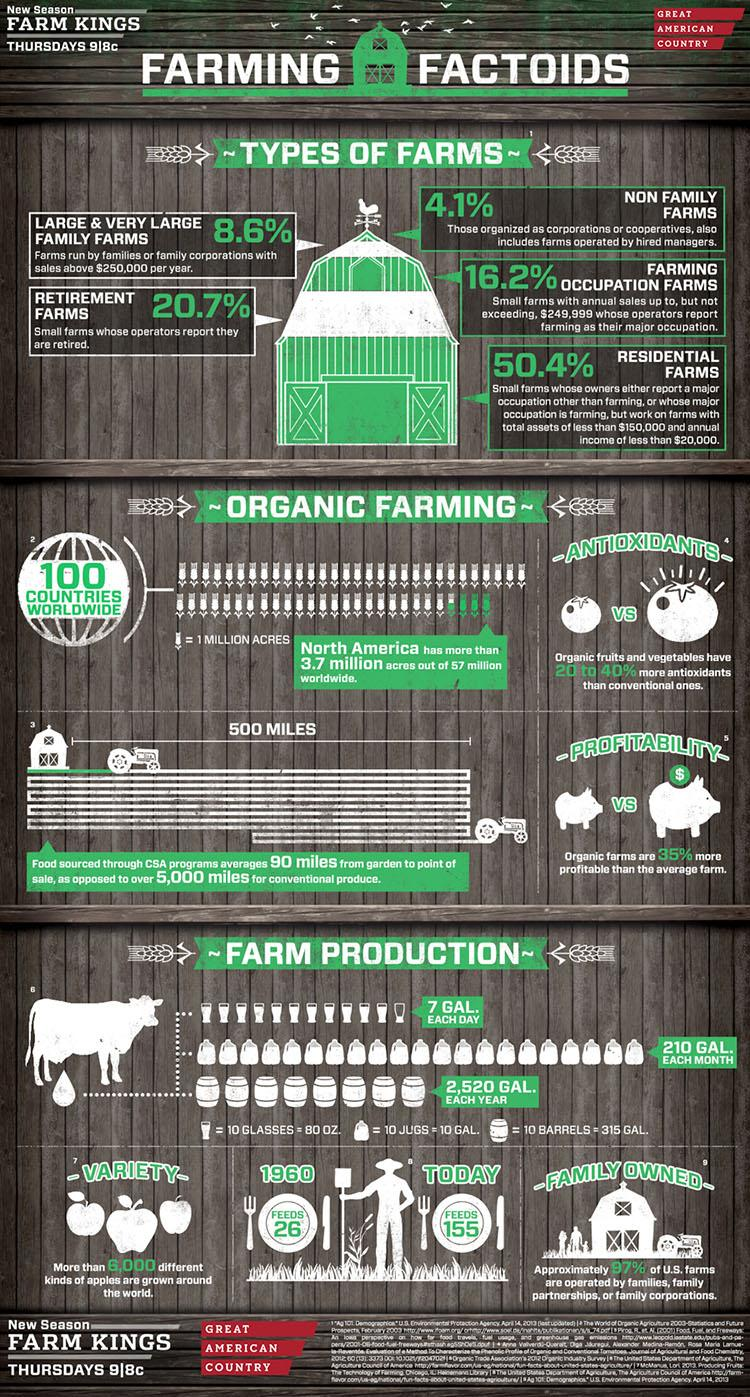Mention a couple of crucial points in this snapshot. Se requieren 112 vasos para almacenar 7 galones de leche al día. It is necessary to use 210 gallons of milk per month and store it in 210 jugs in order to meet the demand. Residential Farms are the most common type of farm that have a low income contribution. There are five types of farms mentioned in the document. Approximately 80 barrels are required to store 2520 gallons of milk annually. 